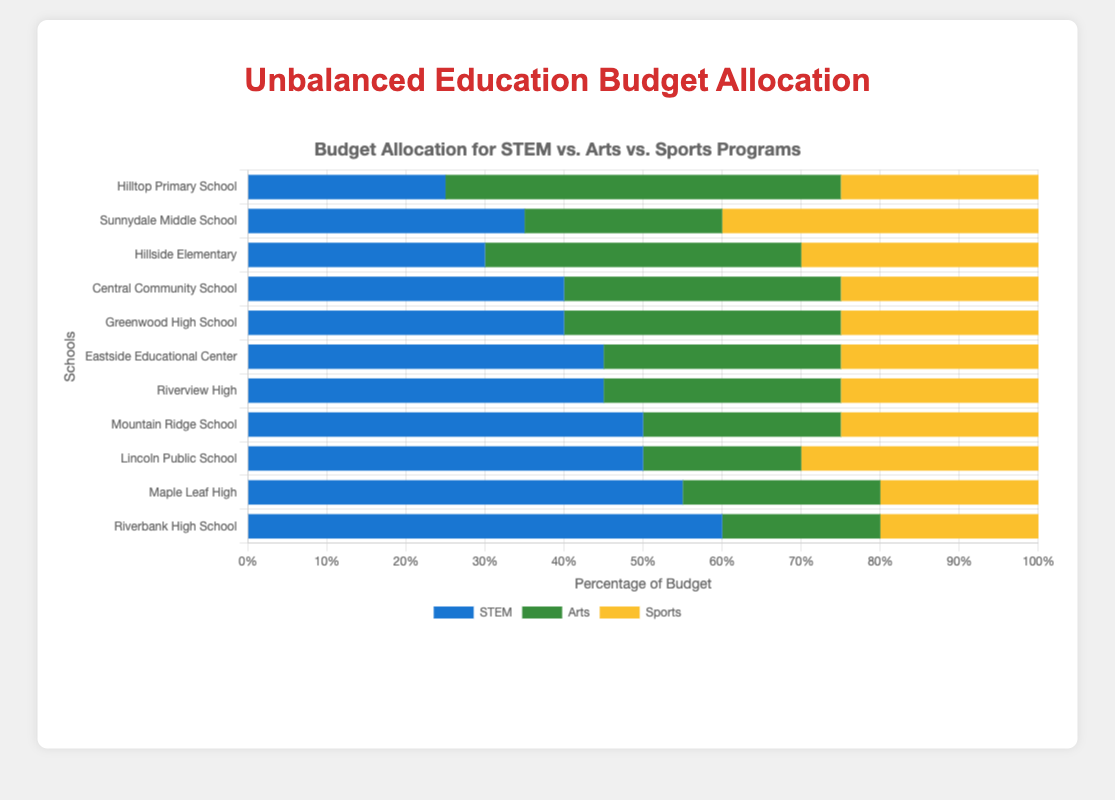Which school allocates the highest percentage of its budget to STEM? By examining the lengths of the blue segments representing STEM budget allocations, Riverbank High School has the longest blue bar, indicating the highest percentage.
Answer: Riverbank High School How much more of its budget does Maple Leaf High allocate to STEM compared to Arts? Maple Leaf High allocates 55% to STEM and 25% to Arts. The difference is 55% - 25% = 30%.
Answer: 30% Which schools allocate exactly 25% of their budget to Sports? By looking at the yellow segments for the Sports budget, identify the schools with a yellow bar length representing 25%. These schools are Greenwood High School, Hillside Elementary, Central Community School, and Mountain Ridge School.
Answer: Greenwood High School, Hillside Elementary, Central Community School, Mountain Ridge School What's the combined budget allocation percentage for Arts and Sports at Sunnydale Middle School? Sunnydale Middle School allocates 25% to Arts and 40% to Sports. The combined percentage is 25% + 40% = 65%.
Answer: 65% Which school has the smallest percentage allocated to Arts? By examining the green segments, Riverbank High School has the shortest green bar, indicating the smallest Arts allocation at 20%.
Answer: Riverbank High School Compare the total budget allocation for non-STEM programs (Arts and Sports) between Lincoln Public School and Greenwood High. Which one has a higher combined percentage? Lincoln Public School: Arts (20%) + Sports (30%) = 50%. Greenwood High School: Arts (35%) + Sports (25%) = 60%. Greenwood High School has a higher combined non-STEM allocation.
Answer: Greenwood High School What's the percentage difference between the highest and lowest STEM allocations? The highest STEM allocation is 60% at Riverbank High School. The lowest STEM allocation is 25% at Hilltop Primary School. The difference is 60% - 25% = 35%.
Answer: 35% Which two schools have equal budget allocations for Arts and Sports? Identifying the segments for Arts and Sports, Central Community School and Riverview High both have 35% Arts and 25% Sports.
Answer: Central Community School, Riverview High Which school allocates an equal percentage of its budget to all three programs? No school allocates an equal percentage to STEM, Arts, and Sports by visually checking the segments for any triple equal lengths.
Answer: None What's the average percentage allocation to STEM for all schools? Summing the STEM allocations: 25 + 35 + 30 + 40 + 40 + 45 + 45 + 50 + 50 + 55 + 60 = 475. There are 11 schools. The average is 475 / 11 ≈ 43.2%.
Answer: 43.2% 